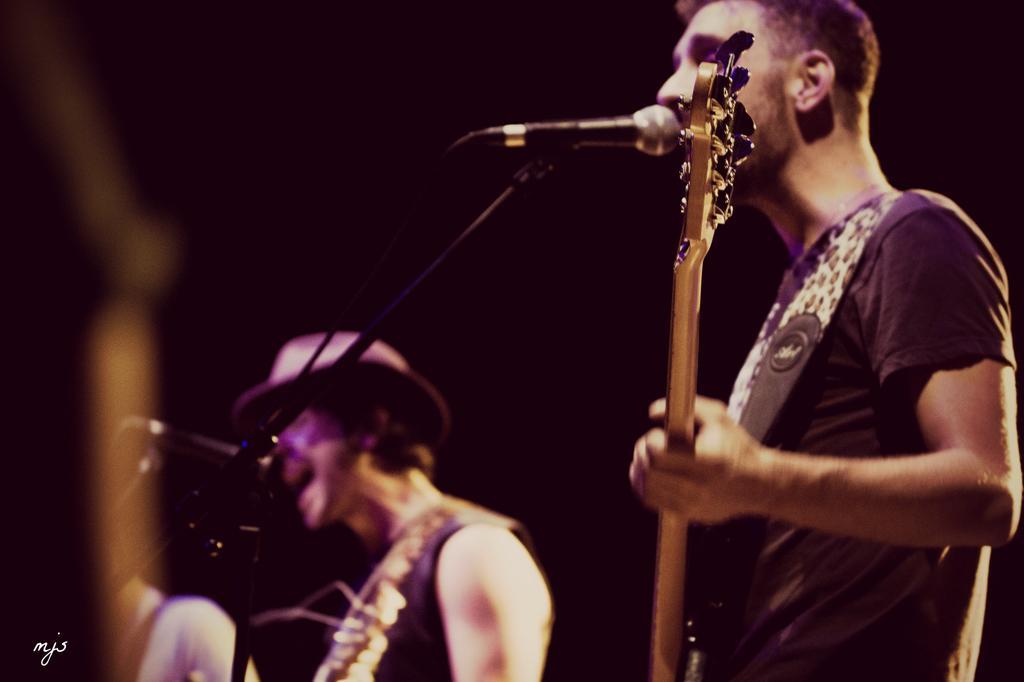Please provide a concise description of this image. This image might be clicked in a musical concert. There are two people. Both of them are man. Both of them are holding guitar and singing something. The one who is on the left side is wearing a hat. Two Mikes are placed in front of them. 